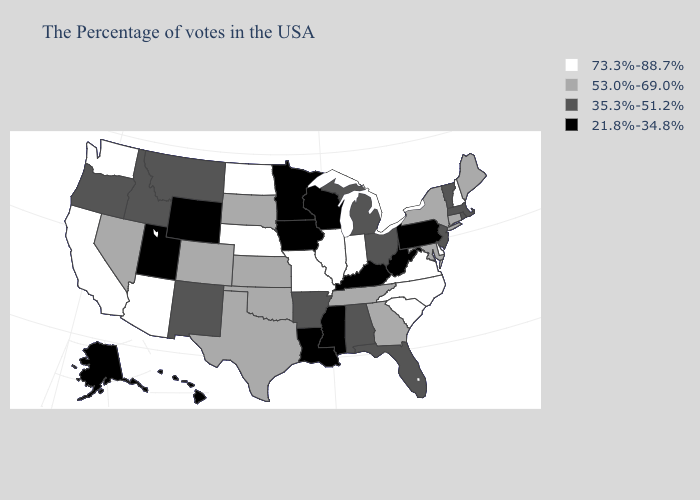Which states hav the highest value in the West?
Give a very brief answer. Arizona, California, Washington. Name the states that have a value in the range 53.0%-69.0%?
Answer briefly. Maine, Connecticut, New York, Maryland, Georgia, Tennessee, Kansas, Oklahoma, Texas, South Dakota, Colorado, Nevada. Does Virginia have the lowest value in the USA?
Concise answer only. No. What is the highest value in the USA?
Concise answer only. 73.3%-88.7%. Which states hav the highest value in the Northeast?
Answer briefly. New Hampshire. Among the states that border North Dakota , which have the highest value?
Give a very brief answer. South Dakota. What is the value of Wyoming?
Answer briefly. 21.8%-34.8%. What is the value of Nebraska?
Be succinct. 73.3%-88.7%. Name the states that have a value in the range 53.0%-69.0%?
Give a very brief answer. Maine, Connecticut, New York, Maryland, Georgia, Tennessee, Kansas, Oklahoma, Texas, South Dakota, Colorado, Nevada. Among the states that border Iowa , which have the lowest value?
Write a very short answer. Wisconsin, Minnesota. Does Rhode Island have a higher value than Minnesota?
Write a very short answer. Yes. Which states hav the highest value in the West?
Give a very brief answer. Arizona, California, Washington. Name the states that have a value in the range 21.8%-34.8%?
Answer briefly. Pennsylvania, West Virginia, Kentucky, Wisconsin, Mississippi, Louisiana, Minnesota, Iowa, Wyoming, Utah, Alaska, Hawaii. Name the states that have a value in the range 21.8%-34.8%?
Concise answer only. Pennsylvania, West Virginia, Kentucky, Wisconsin, Mississippi, Louisiana, Minnesota, Iowa, Wyoming, Utah, Alaska, Hawaii. What is the value of Arkansas?
Answer briefly. 35.3%-51.2%. 